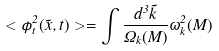Convert formula to latex. <formula><loc_0><loc_0><loc_500><loc_500>< \phi _ { t } ^ { 2 } ( \vec { x } , t ) > = \int \frac { d ^ { 3 } \vec { k } } { \Omega _ { k } ( M ) } \omega _ { k } ^ { 2 } ( M )</formula> 